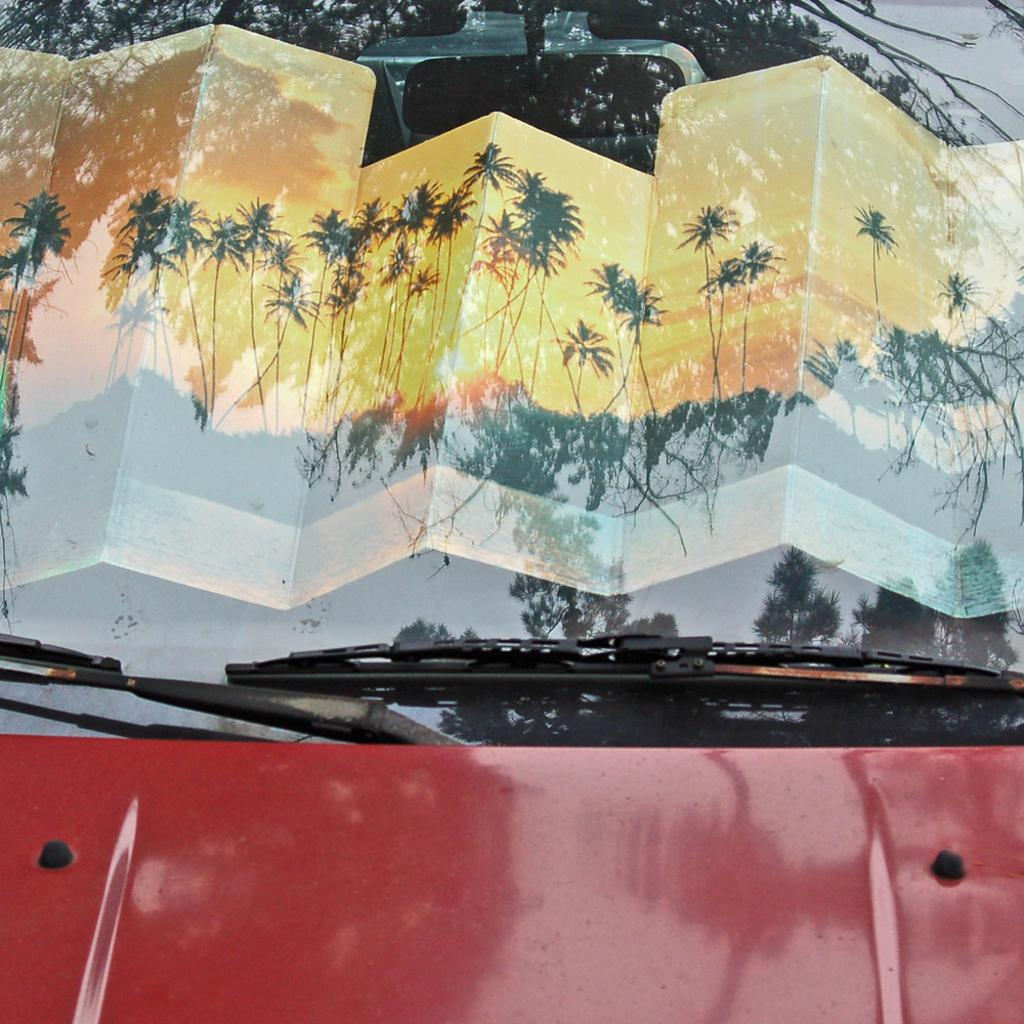What is the main subject of the image? The main subject of the image is a car. Can you describe the car in the image? The car is red. What can be seen in the background of the image? There are many trees visible in the image. What part of the car allows the sky to be seen? The sky is visible through the glass of the car. What type of shame can be seen on the car in the image? There is no shame present in the image; it is a car with no emotional expressions. 